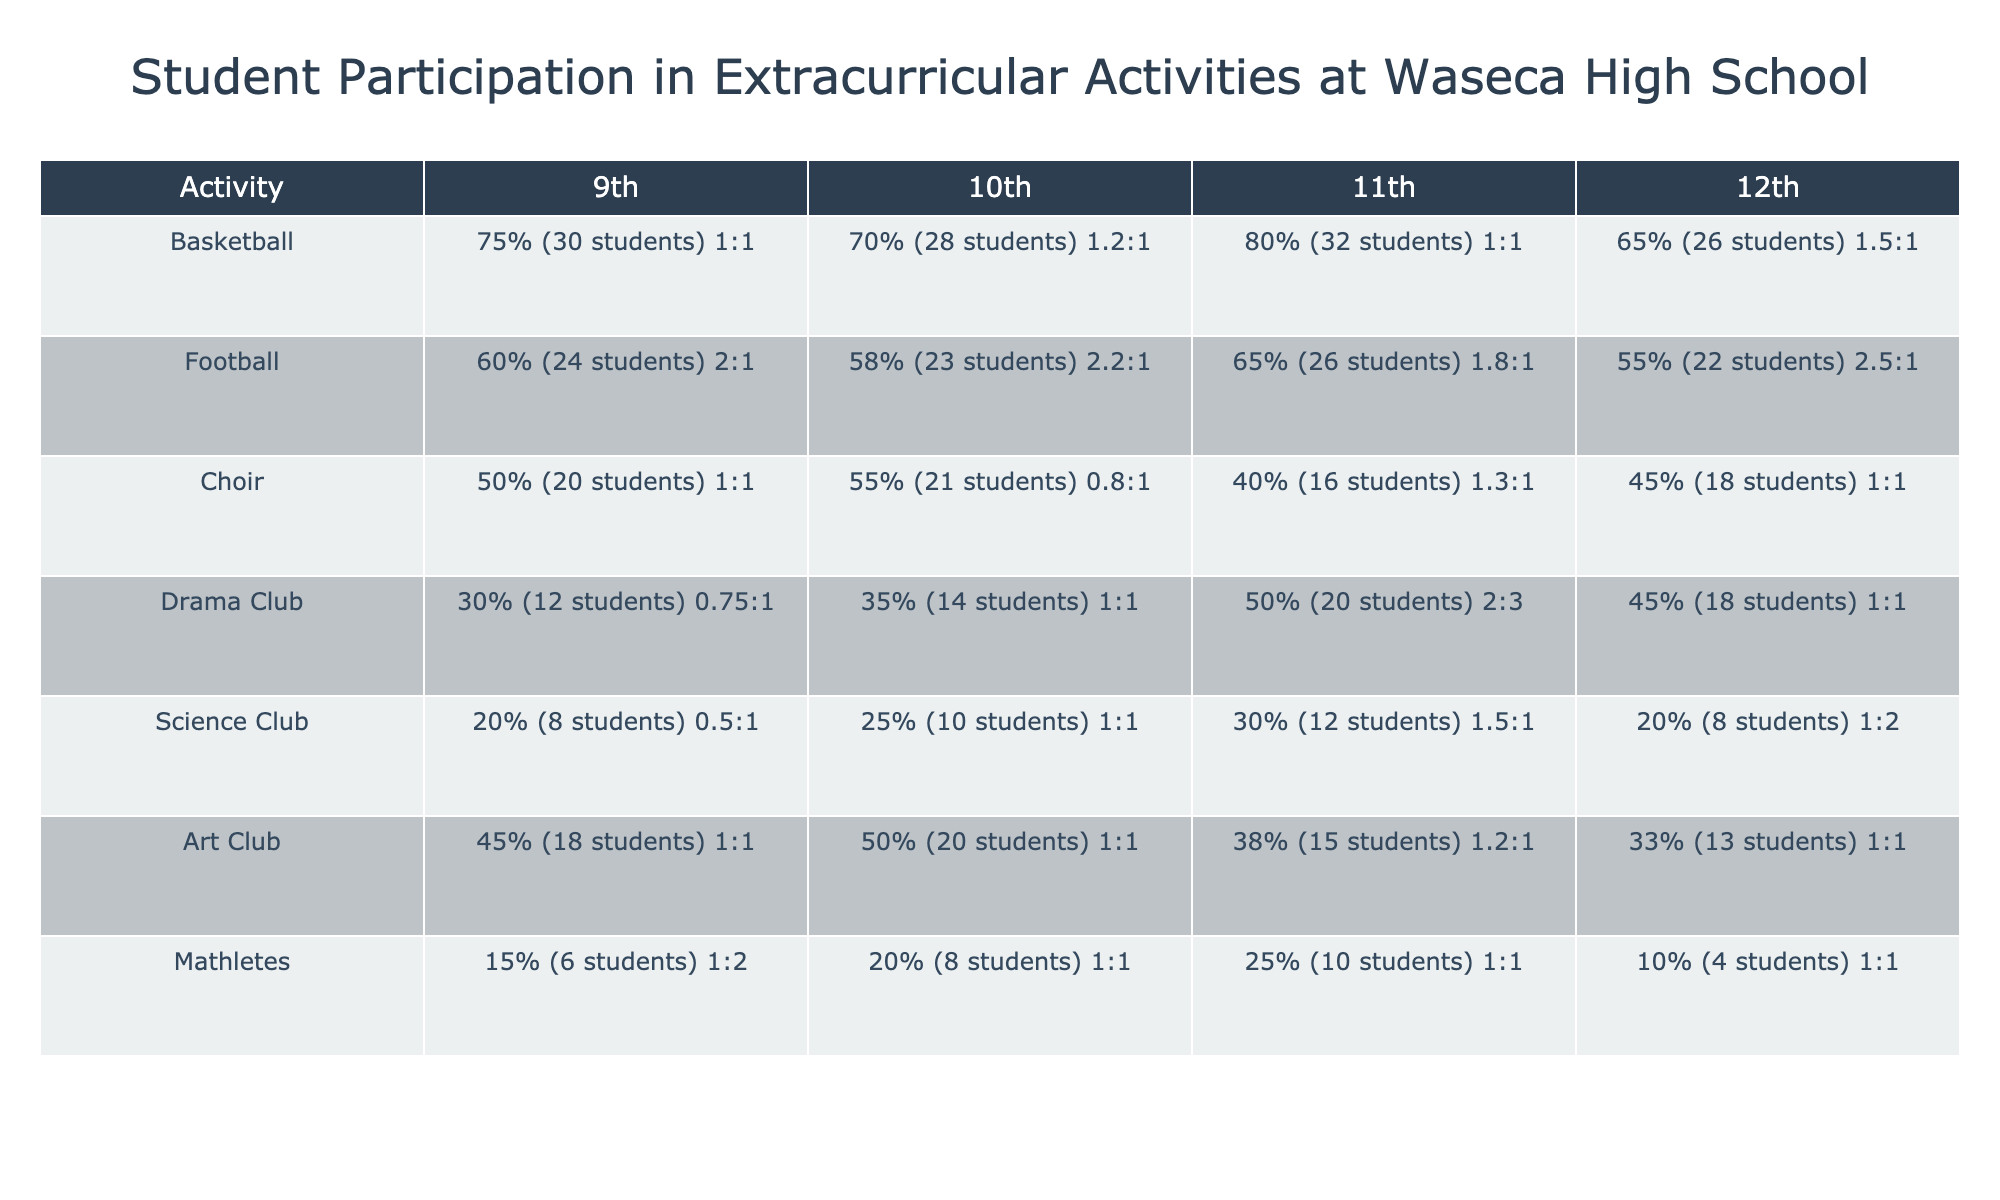What is the participation rate for the 11th grade in the Basketball activity? The table shows that for Basketball, the participation rate in the 11th grade is 80%.
Answer: 80% Which extracurricular activity has the highest participation rate in 9th grade? Looking at the 9th grade column, Basketball has the highest participation rate at 75%.
Answer: Basketball How many students participate in the Choir for the 10th grade? The table indicates that there are 21 students participating in Choir for the 10th grade.
Answer: 21 Is the Gender Ratio for the Football team in 12th grade more favorable to males? The Gender Ratio for Football in 12th grade is 2.5:1, which means there are significantly more males than females.
Answer: Yes What is the average participation rate for the Drama Club across all grades? The participation rates for Drama Club are 30%, 35%, 50%, and 45%. Summing these gives 30 + 35 + 50 + 45 = 160; dividing by 4 grades gives an average of 160/4 = 40%.
Answer: 40% Which activity has the lowest number of students in the 12th grade? The table shows that Mathletes has the lowest number of students in 12th grade with only 4 students.
Answer: Mathletes For which grade level is the participation rate in the Art Club higher than 40%? The participation rates for Art Club are as follows: 9th 45%, 10th 50%, 11th 38%, 12th 33%. Therefore, the 9th and 10th grades have rates above 40%.
Answer: 9th and 10th grades Which activity shows a declining trend in participation rates from 9th to 12th grade? For Football, the participation rates decline from 60% in 9th to 55% in 12th grade, indicating a downward trend.
Answer: Football How many total students are involved in the Science Club across all grades? The number of students in Science Club for each grade is 8, 10, 12, and 8. Summing these gives 8 + 10 + 12 + 8 = 38 students in total.
Answer: 38 Is there a gender bias in the Drama Club based on the Gender Ratio? The Gender Ratio in the Drama Club is 2:3 for 11th grade, which indicates more females than males. Therefore, there is a gender bias toward females in this specific grade.
Answer: Yes 